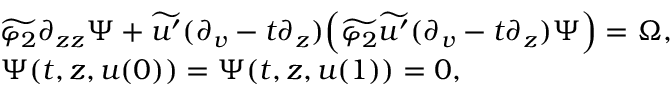Convert formula to latex. <formula><loc_0><loc_0><loc_500><loc_500>\begin{array} { r l } & { \widetilde { \varphi _ { 2 } } \partial _ { z z } \Psi + \widetilde { u ^ { \prime } } ( \partial _ { v } - t \partial _ { z } ) \left ( \widetilde { \varphi _ { 2 } } \widetilde { u ^ { \prime } } ( \partial _ { v } - t \partial _ { z } ) \Psi \right ) = \Omega , } \\ & { \Psi ( t , z , u ( 0 ) ) = \Psi ( t , z , u ( 1 ) ) = 0 , } \end{array}</formula> 